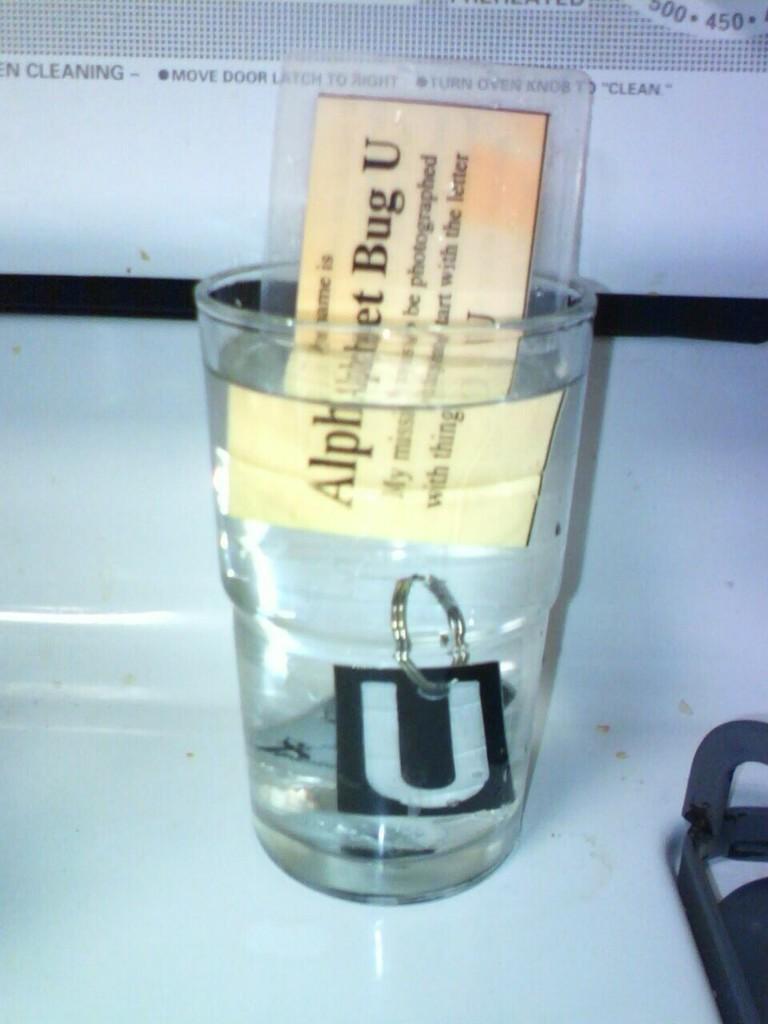What is the letter on the keychain?
Give a very brief answer. U. What word is written in all capital letters?
Make the answer very short. Cleaning. 